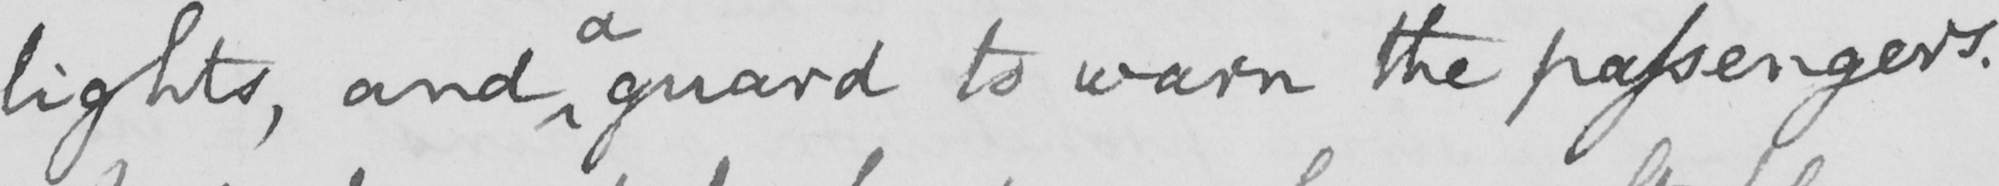Can you read and transcribe this handwriting? lights , and guard to warn the passengers . 